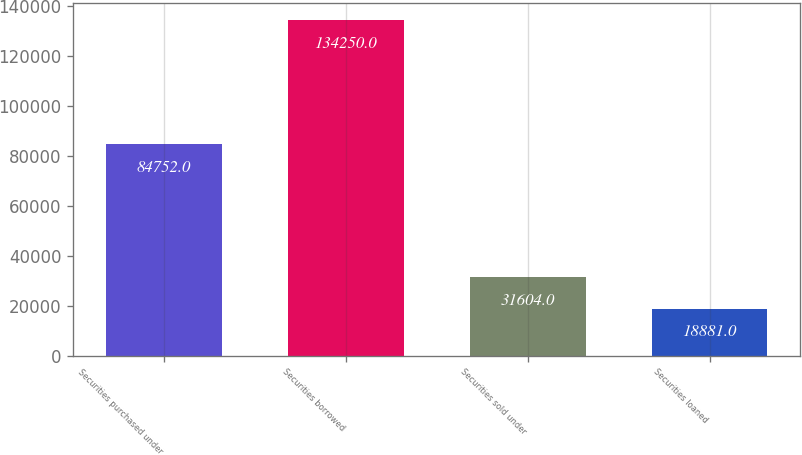Convert chart. <chart><loc_0><loc_0><loc_500><loc_500><bar_chart><fcel>Securities purchased under<fcel>Securities borrowed<fcel>Securities sold under<fcel>Securities loaned<nl><fcel>84752<fcel>134250<fcel>31604<fcel>18881<nl></chart> 